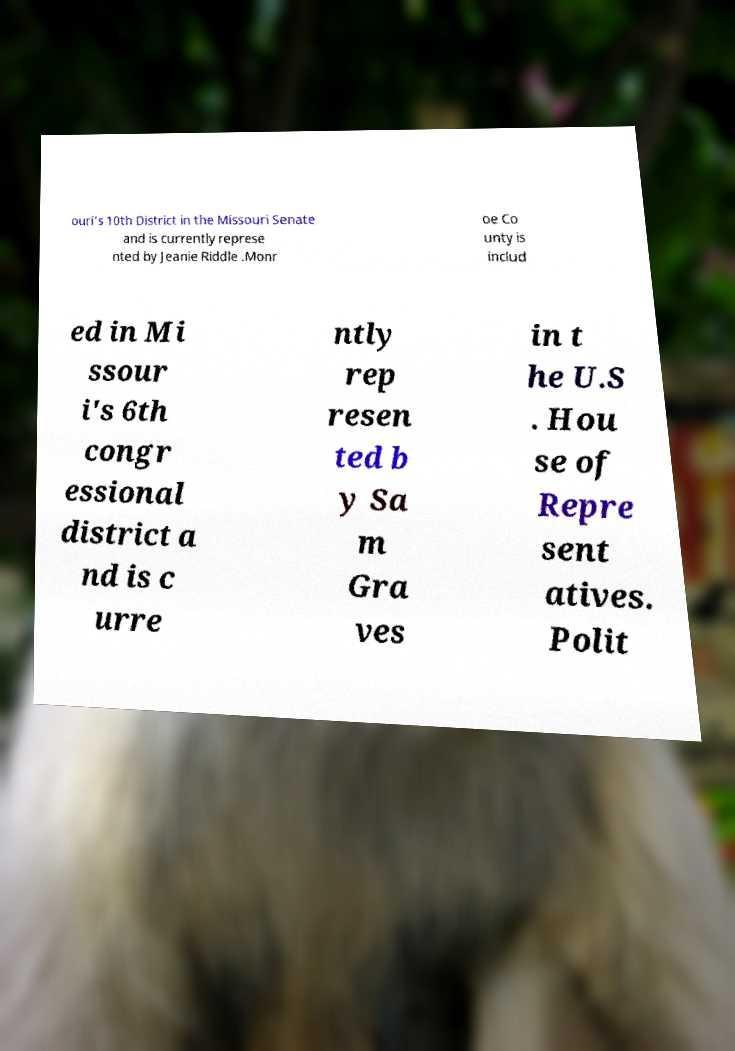For documentation purposes, I need the text within this image transcribed. Could you provide that? ouri's 10th District in the Missouri Senate and is currently represe nted by Jeanie Riddle .Monr oe Co unty is includ ed in Mi ssour i's 6th congr essional district a nd is c urre ntly rep resen ted b y Sa m Gra ves in t he U.S . Hou se of Repre sent atives. Polit 